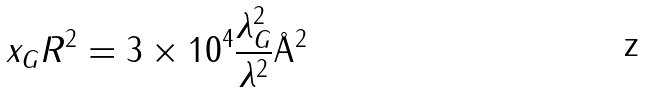<formula> <loc_0><loc_0><loc_500><loc_500>x _ { G } R ^ { 2 } = 3 \times 1 0 ^ { 4 } \frac { \lambda _ { G } ^ { 2 } } { \lambda ^ { 2 } } \AA ^ { 2 }</formula> 